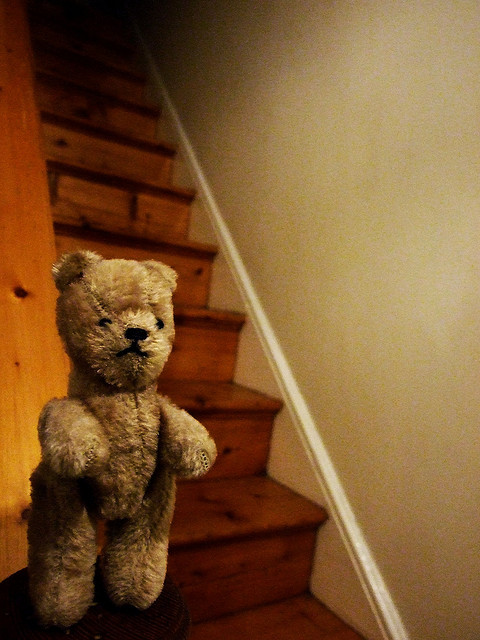<image>Are there any people walking down the stairs? There are no people walking down the stairs. Are there any people walking down the stairs? There are no people walking down the stairs. 